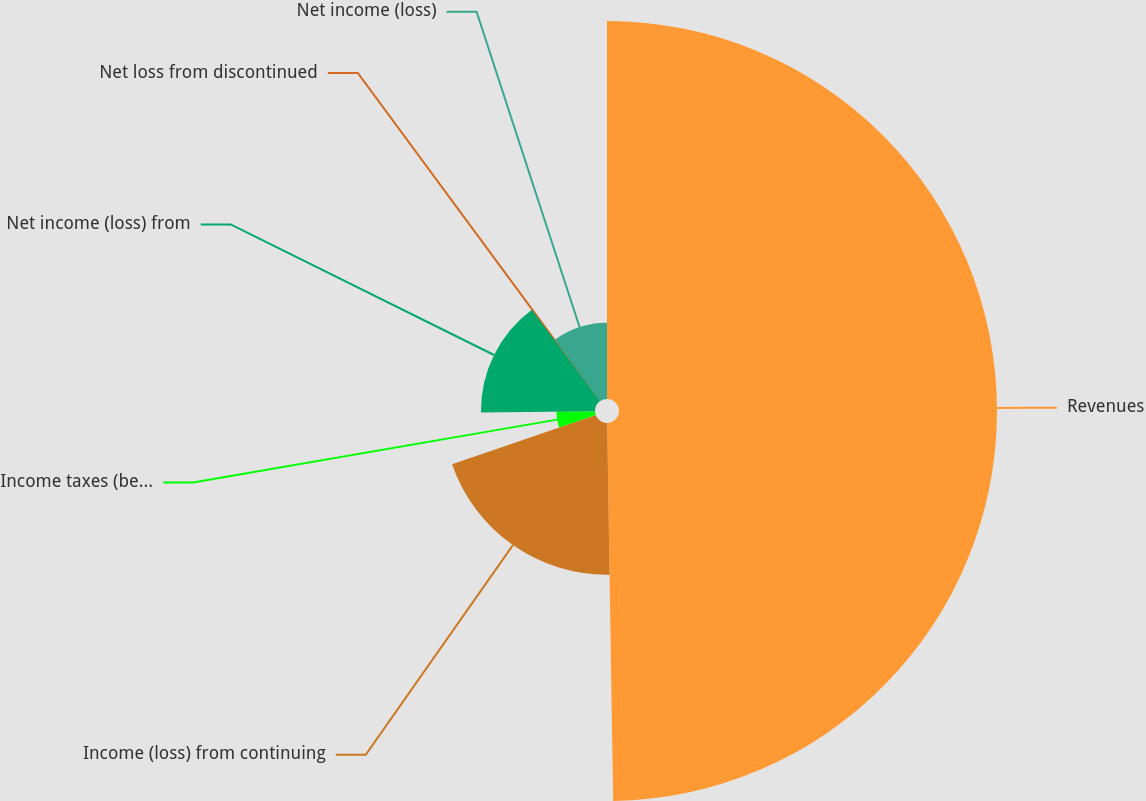<chart> <loc_0><loc_0><loc_500><loc_500><pie_chart><fcel>Revenues<fcel>Income (loss) from continuing<fcel>Income taxes (benefit)<fcel>Net income (loss) from<fcel>Net loss from discontinued<fcel>Net income (loss)<nl><fcel>49.75%<fcel>19.98%<fcel>5.09%<fcel>15.01%<fcel>0.12%<fcel>10.05%<nl></chart> 